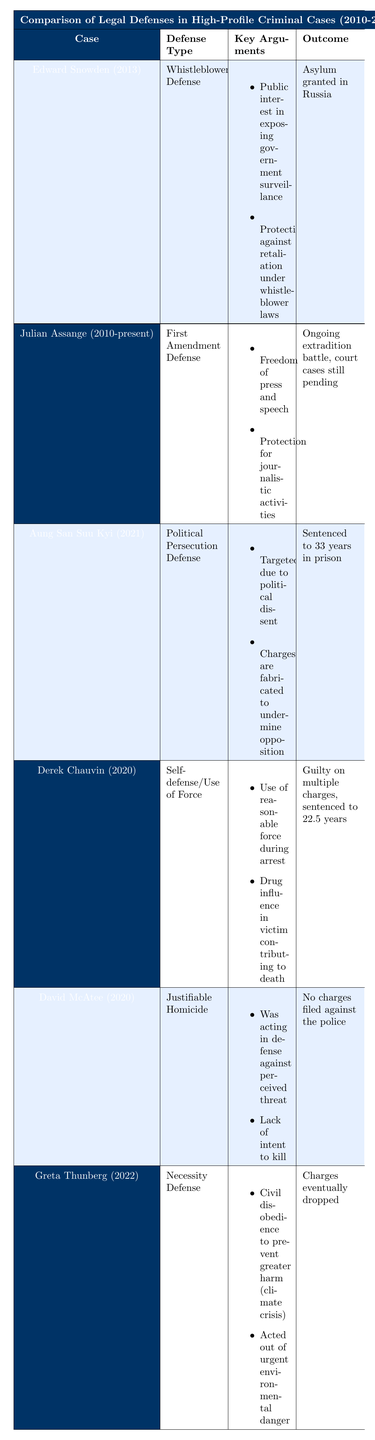What legal defense did Edward Snowden use? Edward Snowden used the "Whistleblower Defense," which is clearly stated in the table under the "Defense Type" column for his case.
Answer: Whistleblower Defense Which case resulted in a guilty verdict? Looking down the "Outcome" column, the row for Derek Chauvin indicates that he was found guilty on multiple charges, while the other cases either had no charges filed or ongoing battles.
Answer: Derek Chauvin What is the defense type used by Julian Assange? The defense type for Julian Assange is "First Amendment Defense," which is listed in the corresponding row of the table.
Answer: First Amendment Defense True or false: Greta Thunberg was sentenced to prison for her actions. Referring to the "Outcome" of Greta Thunberg's case in the table, it states that charges were eventually dropped, which means she was not sentenced to prison.
Answer: False How many cases involved a defense related to political motivation? The table shows that Aung San Suu Kyi and Edward Snowden used defenses related to political motivations (Political Persecution and Whistleblower), while others did not. By counting those specific cases, we find two cases fit this criterion.
Answer: 2 What was the outcome for David McAtee in his case? The "Outcome" column indicates that no charges were filed against the police in David McAtee's case, signifying that he did not face any charges either.
Answer: No charges filed against the police Which defense type was associated with environmental concerns? The defense associated with environmental concerns is the "Necessity Defense," used by Greta Thunberg, as noted in the table.
Answer: Necessity Defense True or false: The legal defenses used by Aung San Suu Kyi and Derek Chauvin are both seen as self-defense. Upon reviewing the defense types in the table, Aung San Suu Kyi used a "Political Persecution Defense," while Derek Chauvin's defense was "Self-defense/Use of Force." Thus, the statement is false.
Answer: False What was the key argument for Derek Chauvin's defense? The table lists specific key arguments for Derek Chauvin's defense, including the claim of using reasonable force during an arrest and the influence of drugs on the victim.
Answer: Use of reasonable force during arrest and drug influence on victim How does the outcome of Aung San Suu Kyi’s case compare to Edward Snowden’s? Aung San Suu Kyi was sentenced to 33 years in prison for her political persecution defense, while Edward Snowden was granted asylum in Russia, showcasing a stark contrast in outcomes.
Answer: Aung San Suu Kyi: sentenced; Edward Snowden: asylum granted 